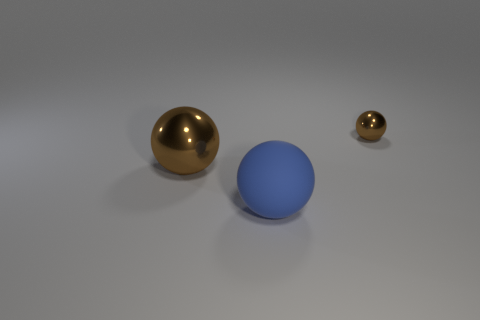Are there any shadows visible, and what do they suggest about the light source? Yes, each object casts a soft shadow, indicating that there is a diffuse light source above them. The shadows are elongated and subtle, suggesting the light might be soft and not too close to the objects. 